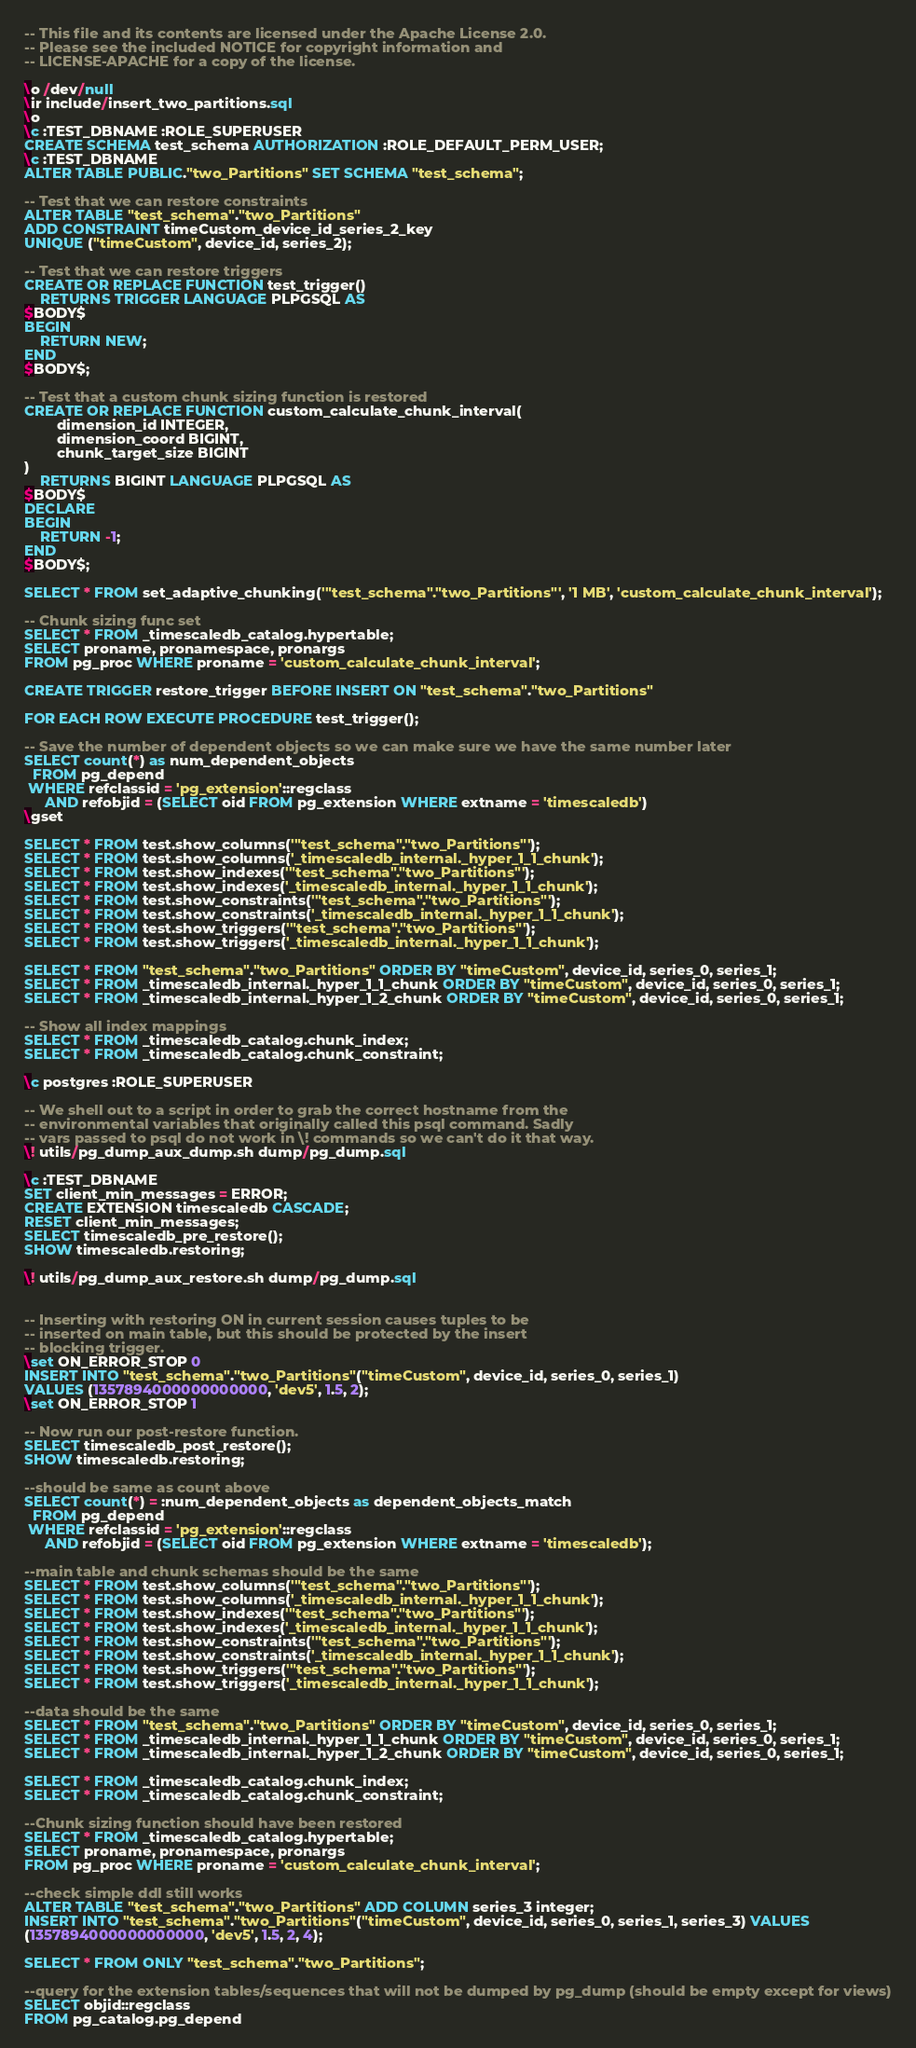<code> <loc_0><loc_0><loc_500><loc_500><_SQL_>-- This file and its contents are licensed under the Apache License 2.0.
-- Please see the included NOTICE for copyright information and
-- LICENSE-APACHE for a copy of the license.

\o /dev/null
\ir include/insert_two_partitions.sql
\o
\c :TEST_DBNAME :ROLE_SUPERUSER
CREATE SCHEMA test_schema AUTHORIZATION :ROLE_DEFAULT_PERM_USER;
\c :TEST_DBNAME
ALTER TABLE PUBLIC."two_Partitions" SET SCHEMA "test_schema";

-- Test that we can restore constraints
ALTER TABLE "test_schema"."two_Partitions"
ADD CONSTRAINT timeCustom_device_id_series_2_key
UNIQUE ("timeCustom", device_id, series_2);

-- Test that we can restore triggers
CREATE OR REPLACE FUNCTION test_trigger()
    RETURNS TRIGGER LANGUAGE PLPGSQL AS
$BODY$
BEGIN
    RETURN NEW;
END
$BODY$;

-- Test that a custom chunk sizing function is restored
CREATE OR REPLACE FUNCTION custom_calculate_chunk_interval(
        dimension_id INTEGER,
        dimension_coord BIGINT,
        chunk_target_size BIGINT
)
    RETURNS BIGINT LANGUAGE PLPGSQL AS
$BODY$
DECLARE
BEGIN
    RETURN -1;
END
$BODY$;

SELECT * FROM set_adaptive_chunking('"test_schema"."two_Partitions"', '1 MB', 'custom_calculate_chunk_interval');

-- Chunk sizing func set
SELECT * FROM _timescaledb_catalog.hypertable;
SELECT proname, pronamespace, pronargs
FROM pg_proc WHERE proname = 'custom_calculate_chunk_interval';

CREATE TRIGGER restore_trigger BEFORE INSERT ON "test_schema"."two_Partitions"

FOR EACH ROW EXECUTE PROCEDURE test_trigger();

-- Save the number of dependent objects so we can make sure we have the same number later
SELECT count(*) as num_dependent_objects
  FROM pg_depend
 WHERE refclassid = 'pg_extension'::regclass
     AND refobjid = (SELECT oid FROM pg_extension WHERE extname = 'timescaledb')
\gset

SELECT * FROM test.show_columns('"test_schema"."two_Partitions"');
SELECT * FROM test.show_columns('_timescaledb_internal._hyper_1_1_chunk');
SELECT * FROM test.show_indexes('"test_schema"."two_Partitions"');
SELECT * FROM test.show_indexes('_timescaledb_internal._hyper_1_1_chunk');
SELECT * FROM test.show_constraints('"test_schema"."two_Partitions"');
SELECT * FROM test.show_constraints('_timescaledb_internal._hyper_1_1_chunk');
SELECT * FROM test.show_triggers('"test_schema"."two_Partitions"');
SELECT * FROM test.show_triggers('_timescaledb_internal._hyper_1_1_chunk');

SELECT * FROM "test_schema"."two_Partitions" ORDER BY "timeCustom", device_id, series_0, series_1;
SELECT * FROM _timescaledb_internal._hyper_1_1_chunk ORDER BY "timeCustom", device_id, series_0, series_1;
SELECT * FROM _timescaledb_internal._hyper_1_2_chunk ORDER BY "timeCustom", device_id, series_0, series_1;

-- Show all index mappings
SELECT * FROM _timescaledb_catalog.chunk_index;
SELECT * FROM _timescaledb_catalog.chunk_constraint;

\c postgres :ROLE_SUPERUSER

-- We shell out to a script in order to grab the correct hostname from the
-- environmental variables that originally called this psql command. Sadly
-- vars passed to psql do not work in \! commands so we can't do it that way.
\! utils/pg_dump_aux_dump.sh dump/pg_dump.sql

\c :TEST_DBNAME
SET client_min_messages = ERROR;
CREATE EXTENSION timescaledb CASCADE;
RESET client_min_messages;
SELECT timescaledb_pre_restore();
SHOW timescaledb.restoring;

\! utils/pg_dump_aux_restore.sh dump/pg_dump.sql


-- Inserting with restoring ON in current session causes tuples to be
-- inserted on main table, but this should be protected by the insert
-- blocking trigger.
\set ON_ERROR_STOP 0
INSERT INTO "test_schema"."two_Partitions"("timeCustom", device_id, series_0, series_1)
VALUES (1357894000000000000, 'dev5', 1.5, 2);
\set ON_ERROR_STOP 1

-- Now run our post-restore function.
SELECT timescaledb_post_restore();
SHOW timescaledb.restoring;

--should be same as count above
SELECT count(*) = :num_dependent_objects as dependent_objects_match
  FROM pg_depend
 WHERE refclassid = 'pg_extension'::regclass
     AND refobjid = (SELECT oid FROM pg_extension WHERE extname = 'timescaledb');

--main table and chunk schemas should be the same
SELECT * FROM test.show_columns('"test_schema"."two_Partitions"');
SELECT * FROM test.show_columns('_timescaledb_internal._hyper_1_1_chunk');
SELECT * FROM test.show_indexes('"test_schema"."two_Partitions"');
SELECT * FROM test.show_indexes('_timescaledb_internal._hyper_1_1_chunk');
SELECT * FROM test.show_constraints('"test_schema"."two_Partitions"');
SELECT * FROM test.show_constraints('_timescaledb_internal._hyper_1_1_chunk');
SELECT * FROM test.show_triggers('"test_schema"."two_Partitions"');
SELECT * FROM test.show_triggers('_timescaledb_internal._hyper_1_1_chunk');

--data should be the same
SELECT * FROM "test_schema"."two_Partitions" ORDER BY "timeCustom", device_id, series_0, series_1;
SELECT * FROM _timescaledb_internal._hyper_1_1_chunk ORDER BY "timeCustom", device_id, series_0, series_1;
SELECT * FROM _timescaledb_internal._hyper_1_2_chunk ORDER BY "timeCustom", device_id, series_0, series_1;

SELECT * FROM _timescaledb_catalog.chunk_index;
SELECT * FROM _timescaledb_catalog.chunk_constraint;

--Chunk sizing function should have been restored
SELECT * FROM _timescaledb_catalog.hypertable;
SELECT proname, pronamespace, pronargs
FROM pg_proc WHERE proname = 'custom_calculate_chunk_interval';

--check simple ddl still works
ALTER TABLE "test_schema"."two_Partitions" ADD COLUMN series_3 integer;
INSERT INTO "test_schema"."two_Partitions"("timeCustom", device_id, series_0, series_1, series_3) VALUES
(1357894000000000000, 'dev5', 1.5, 2, 4);

SELECT * FROM ONLY "test_schema"."two_Partitions";

--query for the extension tables/sequences that will not be dumped by pg_dump (should be empty except for views)
SELECT objid::regclass
FROM pg_catalog.pg_depend</code> 